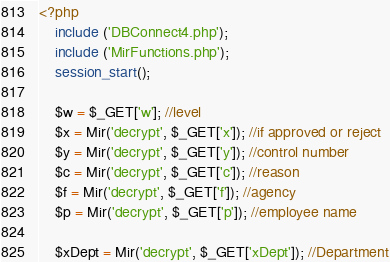<code> <loc_0><loc_0><loc_500><loc_500><_PHP_><?php
	include ('DBConnect4.php');
	include ('MirFunctions.php');
	session_start();

	$w = $_GET['w']; //level
	$x = Mir('decrypt', $_GET['x']); //if approved or reject
	$y = Mir('decrypt', $_GET['y']); //control number
	$c = Mir('decrypt', $_GET['c']); //reason
	$f = Mir('decrypt', $_GET['f']); //agency
    $p = Mir('decrypt', $_GET['p']); //employee name

    $xDept = Mir('decrypt', $_GET['xDept']); //Department</code> 